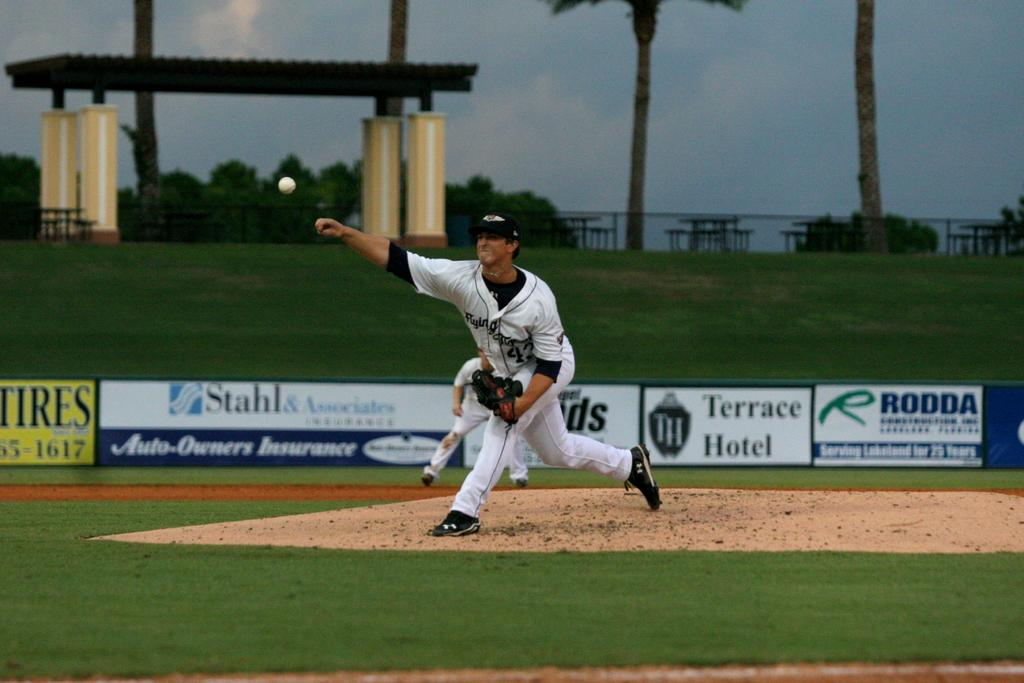<image>
Present a compact description of the photo's key features. A pitcher on a baseball field where one of the sponsors is Terrace Hotel 